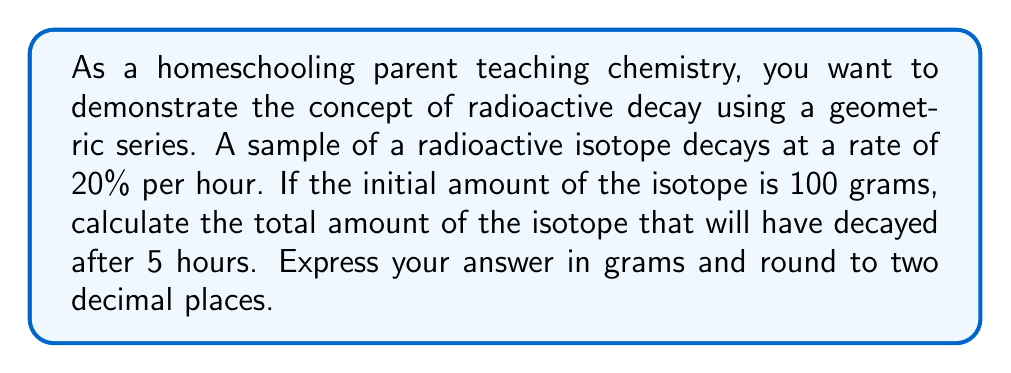Can you solve this math problem? Let's approach this step-by-step:

1) In a geometric series representing decay, each term is a fraction of the previous term. In this case, 20% decays each hour, so 80% remains.

2) The amount remaining after each hour forms a geometric sequence with common ratio $r = 0.8$

3) The amount decayed after each hour is the difference between the initial amount and the amount remaining. This also forms a geometric sequence.

4) Let $a$ be the initial amount (100 grams). The sequence of decay amounts is:

   $a(1-r), ar(1-r), ar^2(1-r), ar^3(1-r), ar^4(1-r)$

5) This is a geometric sequence with first term $a(1-r)$ and common ratio $r$

6) The sum of a geometric series is given by the formula:

   $$S_n = \frac{a(1-r^n)}{1-r}$$

   where $a$ is the first term, $r$ is the common ratio, and $n$ is the number of terms.

7) In our case:
   $a = 100(1-0.8) = 20$
   $r = 0.8$
   $n = 5$

8) Substituting into the formula:

   $$S_5 = \frac{20(1-0.8^5)}{1-0.8} = \frac{20(1-0.32768)}{0.2} = \frac{20(0.67232)}{0.2}$$

9) Calculating:

   $$S_5 = \frac{13.4464}{0.2} = 67.232$$

10) Rounding to two decimal places: 67.23
Answer: 67.23 grams 